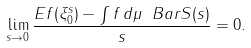Convert formula to latex. <formula><loc_0><loc_0><loc_500><loc_500>\lim _ { s \rightarrow 0 } \frac { E f ( \xi ^ { s } _ { 0 } ) - \int f \, d \mu \ B a r { S } ( s ) } { s } = 0 .</formula> 